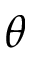Convert formula to latex. <formula><loc_0><loc_0><loc_500><loc_500>\theta</formula> 